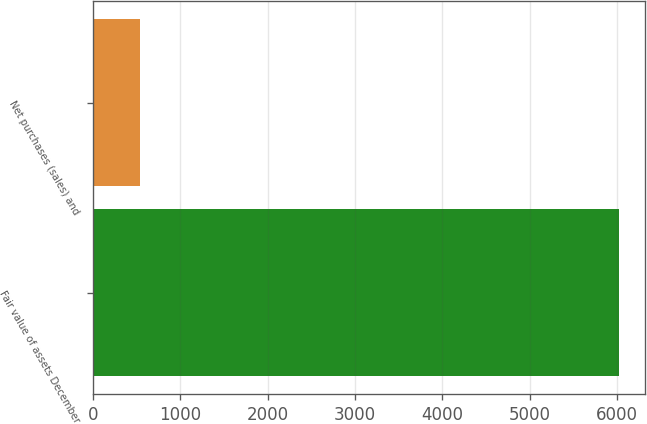<chart> <loc_0><loc_0><loc_500><loc_500><bar_chart><fcel>Fair value of assets December<fcel>Net purchases (sales) and<nl><fcel>6018<fcel>535<nl></chart> 